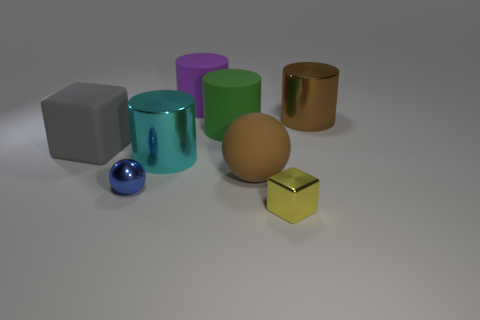Add 1 large gray shiny cubes. How many objects exist? 9 Subtract all cubes. How many objects are left? 6 Subtract all large green cylinders. Subtract all blocks. How many objects are left? 5 Add 1 tiny blue spheres. How many tiny blue spheres are left? 2 Add 1 large blue metallic things. How many large blue metallic things exist? 1 Subtract 0 cyan balls. How many objects are left? 8 